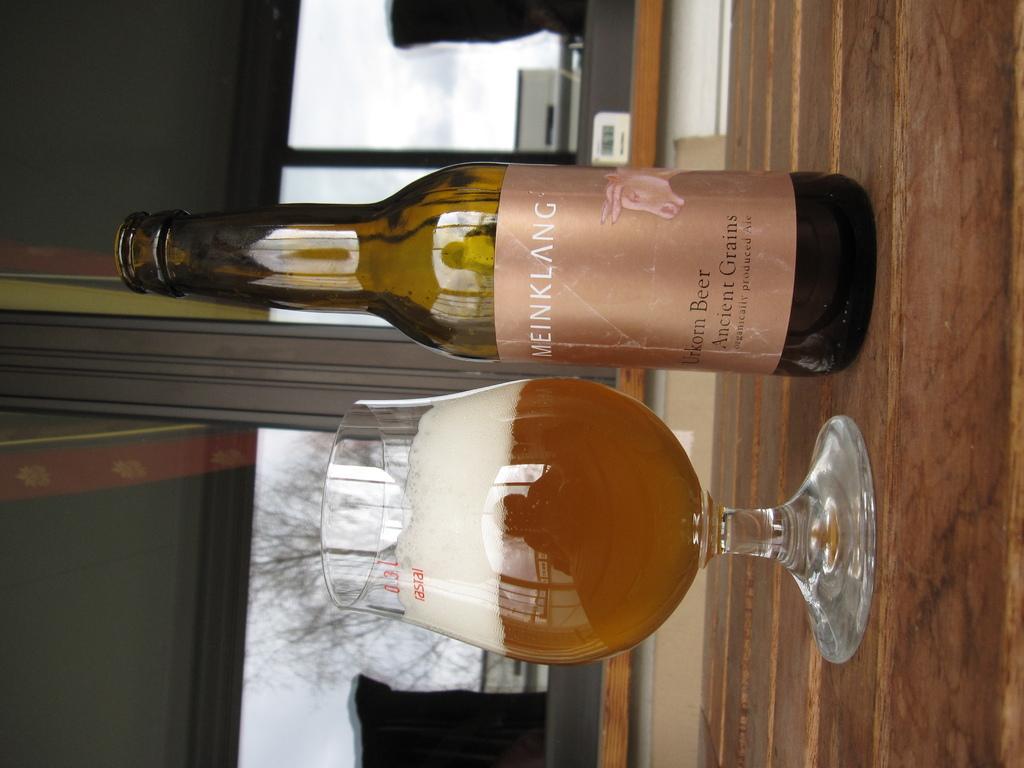Can you describe this image briefly? In the image, there is a liquor bottle and a glass filled with beverage kept on the table. In the middle of the image, a window is visible through which tree is visible. In the left wall is visible of green in color. It looks as if the image is taken inside the house. 